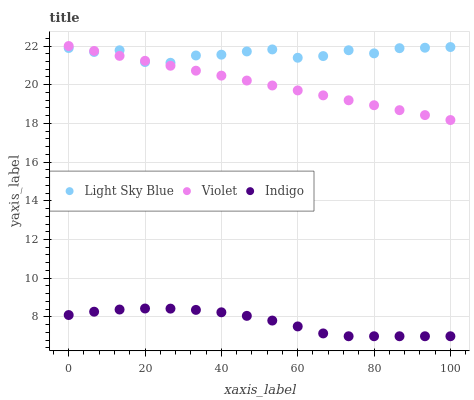Does Indigo have the minimum area under the curve?
Answer yes or no. Yes. Does Light Sky Blue have the maximum area under the curve?
Answer yes or no. Yes. Does Violet have the minimum area under the curve?
Answer yes or no. No. Does Violet have the maximum area under the curve?
Answer yes or no. No. Is Violet the smoothest?
Answer yes or no. Yes. Is Light Sky Blue the roughest?
Answer yes or no. Yes. Is Indigo the smoothest?
Answer yes or no. No. Is Indigo the roughest?
Answer yes or no. No. Does Indigo have the lowest value?
Answer yes or no. Yes. Does Violet have the lowest value?
Answer yes or no. No. Does Violet have the highest value?
Answer yes or no. Yes. Does Indigo have the highest value?
Answer yes or no. No. Is Indigo less than Light Sky Blue?
Answer yes or no. Yes. Is Violet greater than Indigo?
Answer yes or no. Yes. Does Violet intersect Light Sky Blue?
Answer yes or no. Yes. Is Violet less than Light Sky Blue?
Answer yes or no. No. Is Violet greater than Light Sky Blue?
Answer yes or no. No. Does Indigo intersect Light Sky Blue?
Answer yes or no. No. 